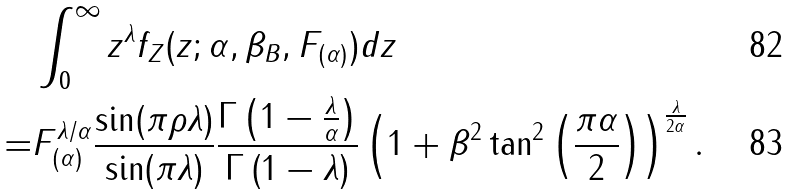<formula> <loc_0><loc_0><loc_500><loc_500>& \int _ { 0 } ^ { \infty } z ^ { \lambda } f _ { Z } ( z ; \alpha , \beta _ { B } , F _ { ( \alpha ) } ) d z \\ = & F ^ { \lambda / \alpha } _ { ( \alpha ) } \frac { \sin ( \pi \rho \lambda ) } { \sin ( \pi \lambda ) } \frac { \Gamma \left ( 1 - \frac { \lambda } { \alpha } \right ) } { \Gamma \left ( 1 - \lambda \right ) } \left ( 1 + \beta ^ { 2 } \tan ^ { 2 } \left ( \frac { \pi \alpha } { 2 } \right ) \right ) ^ { \frac { \lambda } { 2 \alpha } } .</formula> 